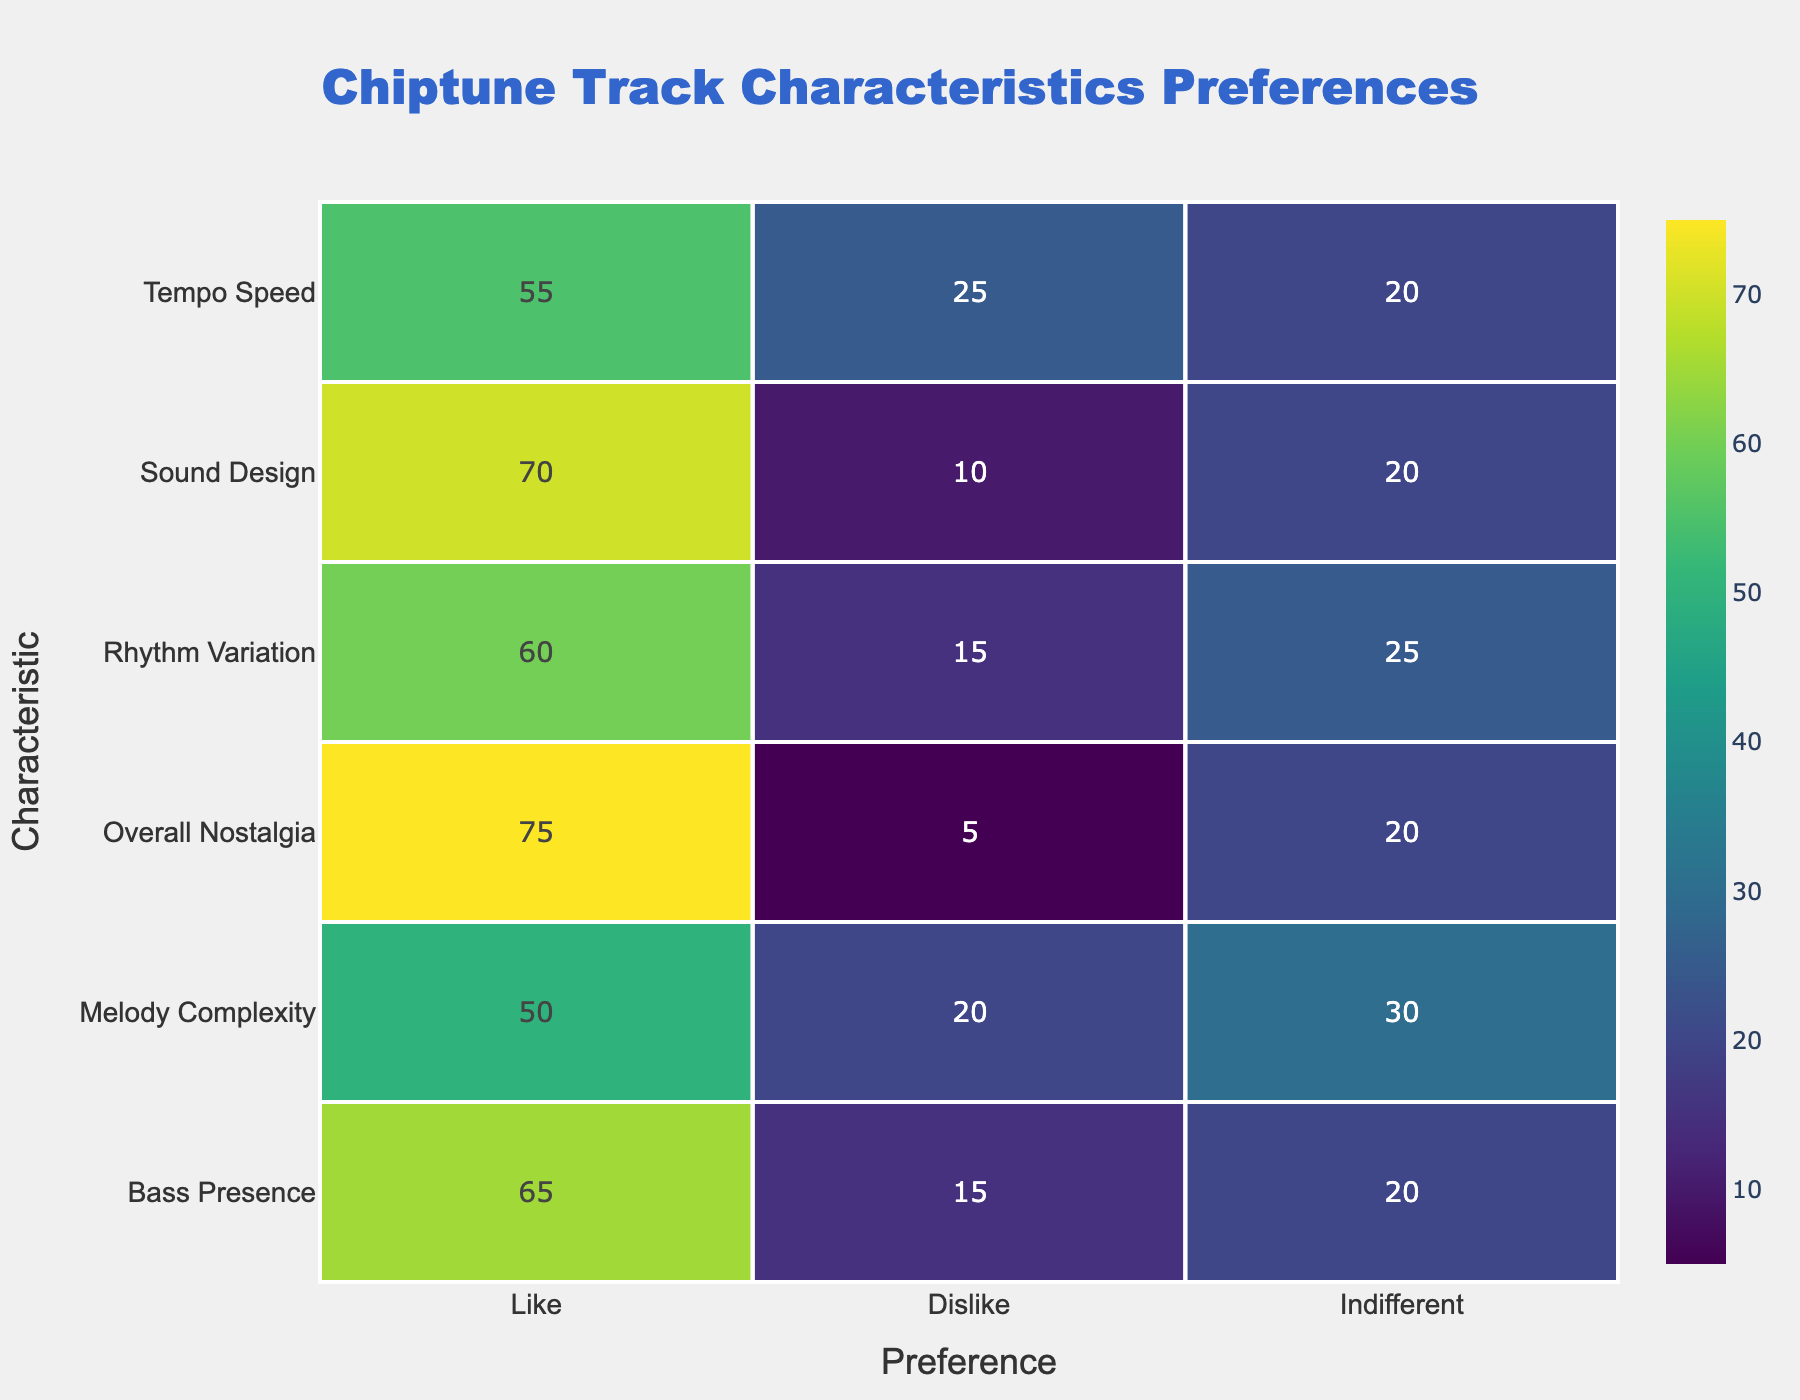What is the highest count for any characteristic being liked? The "Overall Nostalgia" characteristic has the highest count for "Like," which is 75. This is the maximum number in the "Like" column after reviewing all the characteristics.
Answer: 75 Which characteristic has the lowest count for indifference? The "Sound Design" characteristic has an indifference count of 20, which is the lowest compared to the other characteristics. By looking at the "Indifferent" row, this value stands out as the smallest.
Answer: 20 What is the total count of listeners who dislike any characteristic? To find the total count for dislikes, we sum the dislikes for all characteristics: 20 (Melody Complexity) + 15 (Rhythm Variation) + 10 (Sound Design) + 25 (Tempo Speed) + 5 (Overall Nostalgia) + 15 (Bass Presence) = 80. This involves adding all the "Dislike" values together from the respective rows.
Answer: 80 Is there a characteristic that has an equal count of listeners who like and dislike it? No, each characteristic has a different count for likes and dislikes, meaning there is no characteristic with equal like and dislike counts. By examining each row, this can be verified as no pairs share the same value between "Like" and "Dislike."
Answer: No Which characteristic has the highest number of listeners who are indifferent? The "Melody Complexity" characteristic has the highest count of indifference, totaling 30. This is determined by comparing the indifference counts across each characteristic in the "Indifferent" column.
Answer: 30 What is the difference in the number of people who liked "Sound Design" compared to those who disliked it? The count for "Like" in "Sound Design" is 70, and the count for "Dislike" is 10. The difference can be calculated as 70 - 10 = 60, showing a significant preference for "Sound Design."
Answer: 60 Overall, how many listeners liked the Rhythm Variation and Tempo Speed characteristics combined? To find this, we sum the "Like" counts for both characteristics: 60 (Rhythm Variation) + 55 (Tempo Speed) = 115. This involves adding the values from these two corresponding rows in the table.
Answer: 115 What is the total number of listeners surveyed based on the counts provided? By adding all the counts from each characteristic, we calculate 50 + 20 + 30 + 60 + 15 + 25 + 70 + 10 + 20 + 55 + 25 + 20 + 75 + 5 + 20 + 65 + 15 + 20 = 570. This gives the total number of listeners considered in the survey.
Answer: 570 